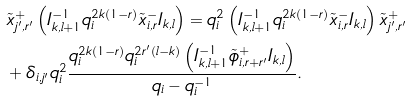Convert formula to latex. <formula><loc_0><loc_0><loc_500><loc_500>& \tilde { x } _ { j ^ { \prime } , r ^ { \prime } } ^ { + } \left ( I _ { k , l + 1 } ^ { - 1 } q _ { i } ^ { 2 k ( 1 - r ) } \tilde { x } _ { i , r } ^ { - } I _ { k , l } \right ) = q _ { i } ^ { 2 } \left ( I _ { k , l + 1 } ^ { - 1 } q _ { i } ^ { 2 k ( 1 - r ) } \tilde { x } _ { i , r } ^ { - } I _ { k , l } \right ) \tilde { x } _ { j ^ { \prime } , r ^ { \prime } } ^ { + } \\ & + \delta _ { i , j ^ { \prime } } q _ { i } ^ { 2 } \frac { q _ { i } ^ { 2 k ( 1 - r ) } q _ { i } ^ { 2 r ^ { \prime } ( l - k ) } \left ( I _ { k , l + 1 } ^ { - 1 } \tilde { \phi } _ { i , r + r ^ { \prime } } ^ { + } I _ { k , l } \right ) } { q _ { i } - q _ { i } ^ { - 1 } } .</formula> 